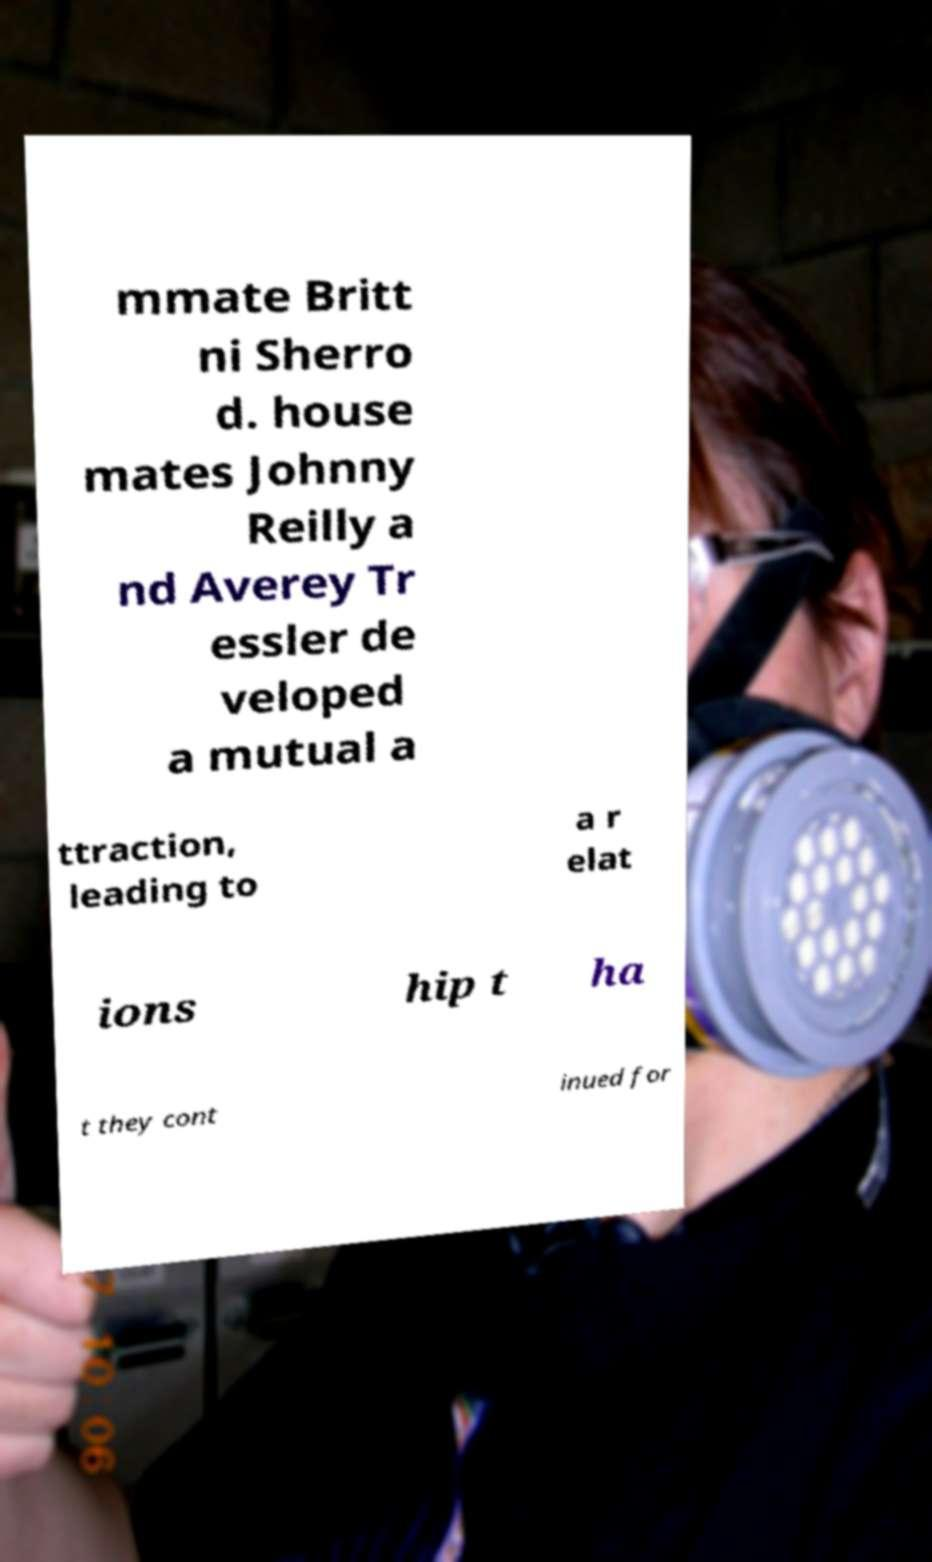I need the written content from this picture converted into text. Can you do that? mmate Britt ni Sherro d. house mates Johnny Reilly a nd Averey Tr essler de veloped a mutual a ttraction, leading to a r elat ions hip t ha t they cont inued for 